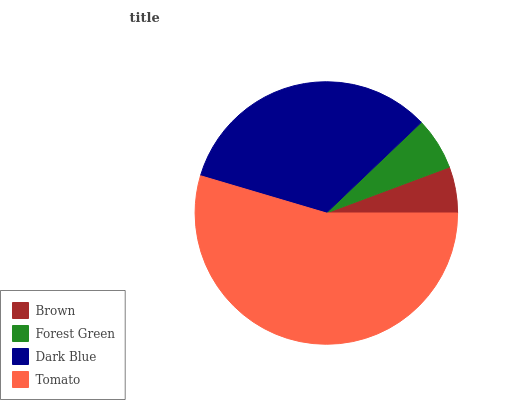Is Brown the minimum?
Answer yes or no. Yes. Is Tomato the maximum?
Answer yes or no. Yes. Is Forest Green the minimum?
Answer yes or no. No. Is Forest Green the maximum?
Answer yes or no. No. Is Forest Green greater than Brown?
Answer yes or no. Yes. Is Brown less than Forest Green?
Answer yes or no. Yes. Is Brown greater than Forest Green?
Answer yes or no. No. Is Forest Green less than Brown?
Answer yes or no. No. Is Dark Blue the high median?
Answer yes or no. Yes. Is Forest Green the low median?
Answer yes or no. Yes. Is Brown the high median?
Answer yes or no. No. Is Dark Blue the low median?
Answer yes or no. No. 